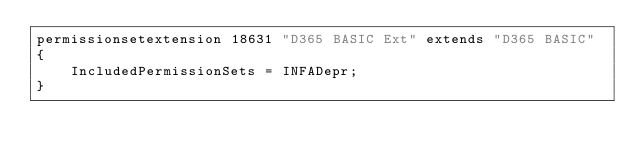<code> <loc_0><loc_0><loc_500><loc_500><_Perl_>permissionsetextension 18631 "D365 BASIC Ext" extends "D365 BASIC"
{
    IncludedPermissionSets = INFADepr;
}</code> 